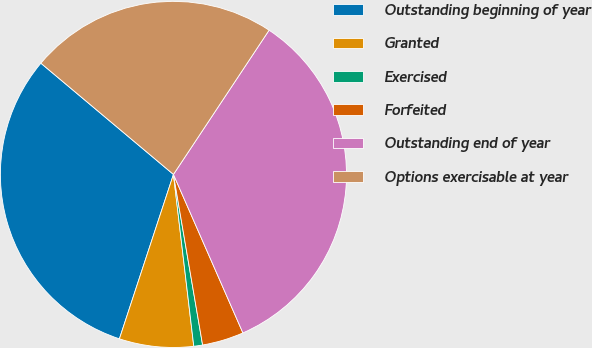Convert chart to OTSL. <chart><loc_0><loc_0><loc_500><loc_500><pie_chart><fcel>Outstanding beginning of year<fcel>Granted<fcel>Exercised<fcel>Forfeited<fcel>Outstanding end of year<fcel>Options exercisable at year<nl><fcel>31.06%<fcel>6.93%<fcel>0.82%<fcel>3.88%<fcel>34.11%<fcel>23.21%<nl></chart> 